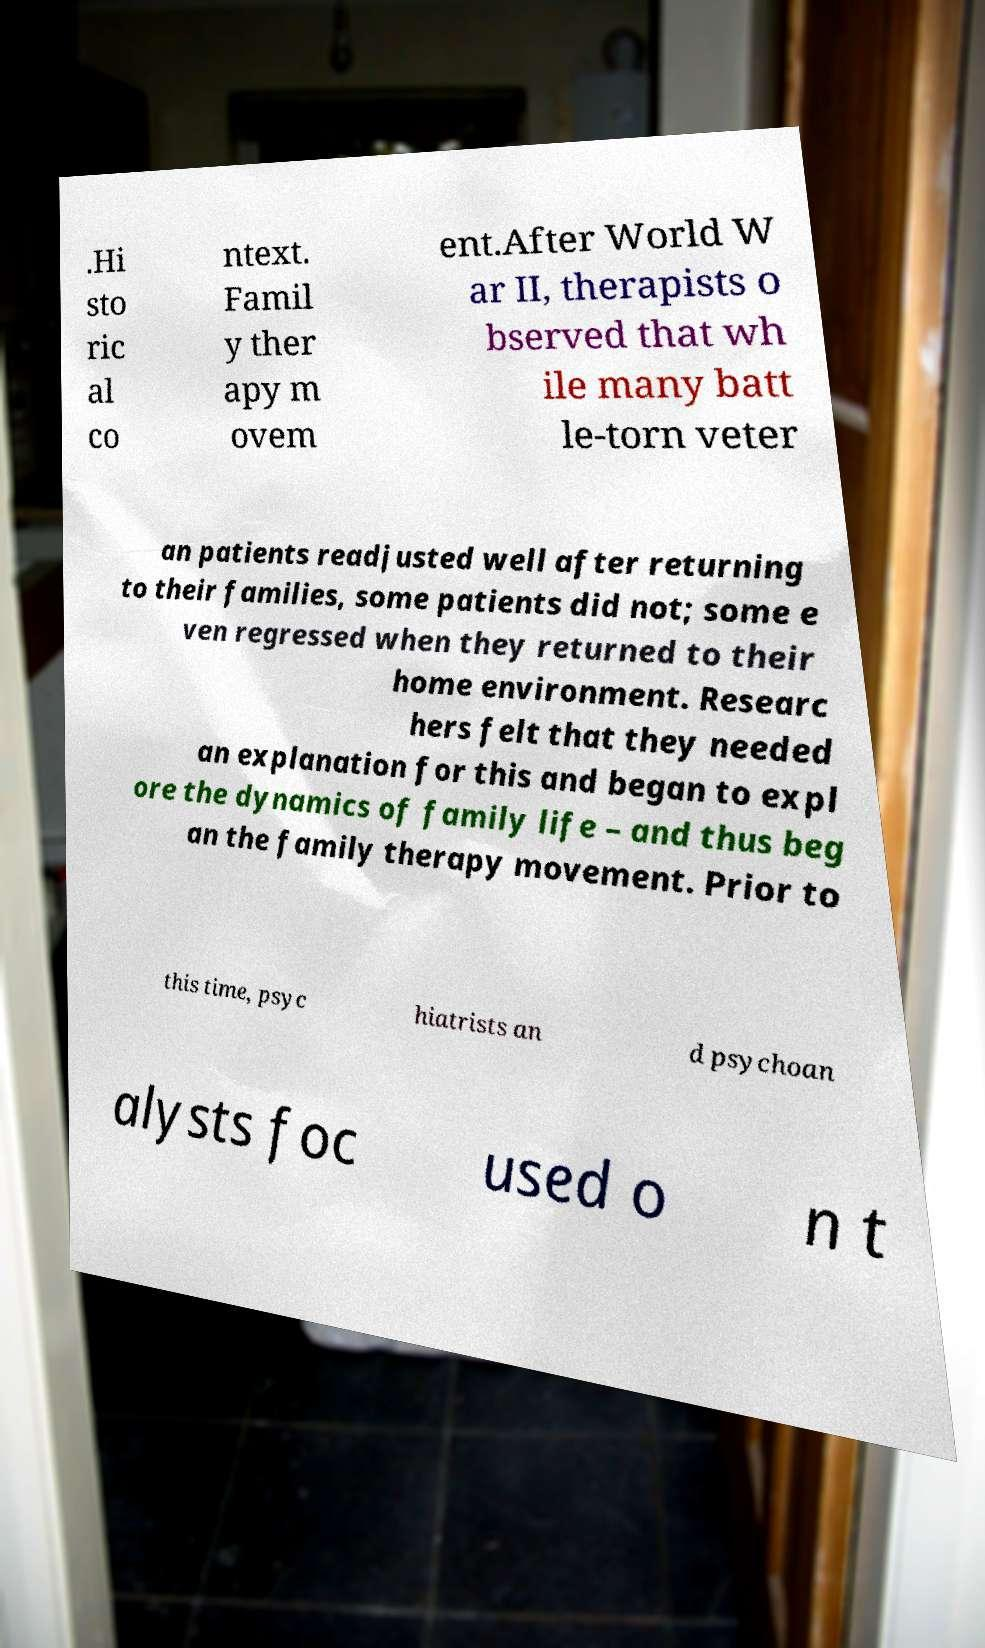Can you read and provide the text displayed in the image?This photo seems to have some interesting text. Can you extract and type it out for me? .Hi sto ric al co ntext. Famil y ther apy m ovem ent.After World W ar II, therapists o bserved that wh ile many batt le-torn veter an patients readjusted well after returning to their families, some patients did not; some e ven regressed when they returned to their home environment. Researc hers felt that they needed an explanation for this and began to expl ore the dynamics of family life – and thus beg an the family therapy movement. Prior to this time, psyc hiatrists an d psychoan alysts foc used o n t 